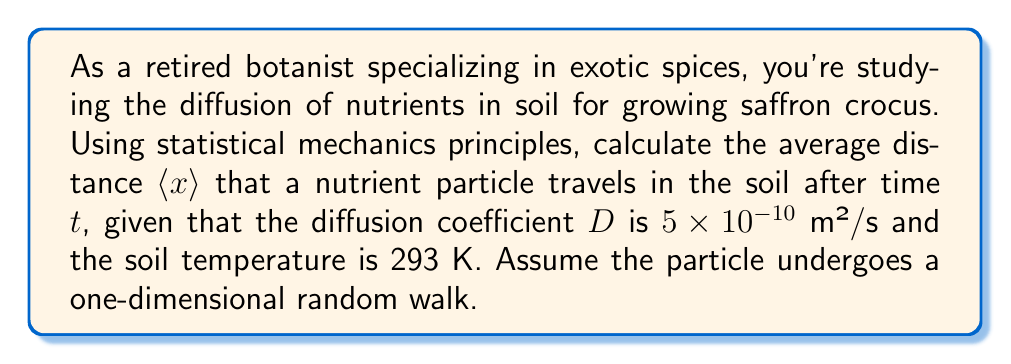Solve this math problem. To solve this problem, we'll use the principles of statistical mechanics and diffusion:

1. In a one-dimensional random walk, the mean square displacement $\langle x^2 \rangle$ is related to the diffusion coefficient $D$ and time $t$ by:

   $$\langle x^2 \rangle = 2Dt$$

2. However, we're asked for the average distance $\langle x \rangle$, not the mean square displacement. For a one-dimensional random walk, the relationship between $\langle x \rangle$ and $\langle x^2 \rangle$ is:

   $$\langle x \rangle = \sqrt{\frac{2}{\pi}\langle x^2 \rangle}$$

3. Substituting the expression for $\langle x^2 \rangle$ into this equation:

   $$\langle x \rangle = \sqrt{\frac{2}{\pi}(2Dt)}$$

4. Simplifying:

   $$\langle x \rangle = \sqrt{\frac{4Dt}{\pi}}$$

5. Now, let's substitute the given values:
   $D = 5 \times 10^{-10}$ m²/s
   $t = 1$ day = 86400 s (assuming we're interested in the distance after one day)

   $$\langle x \rangle = \sqrt{\frac{4 \cdot (5 \times 10^{-10}) \cdot 86400}{\pi}}$$

6. Calculating:

   $$\langle x \rangle = \sqrt{\frac{1.728 \times 10^{-4}}{\pi}} \approx 0.00235 \text{ m}$$

7. Converting to millimeters for a more practical unit in botany:

   $$\langle x \rangle \approx 2.35 \text{ mm}$$
Answer: 2.35 mm 